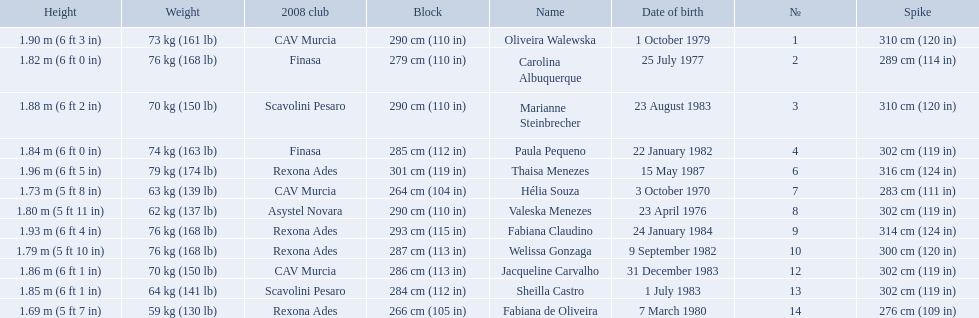What are the names of all the contestants? Oliveira Walewska, Carolina Albuquerque, Marianne Steinbrecher, Paula Pequeno, Thaisa Menezes, Hélia Souza, Valeska Menezes, Fabiana Claudino, Welissa Gonzaga, Jacqueline Carvalho, Sheilla Castro, Fabiana de Oliveira. What are the weight ranges of the contestants? 73 kg (161 lb), 76 kg (168 lb), 70 kg (150 lb), 74 kg (163 lb), 79 kg (174 lb), 63 kg (139 lb), 62 kg (137 lb), 76 kg (168 lb), 76 kg (168 lb), 70 kg (150 lb), 64 kg (141 lb), 59 kg (130 lb). Which player is heaviest. sheilla castro, fabiana de oliveira, or helia souza? Sheilla Castro. 